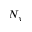Convert formula to latex. <formula><loc_0><loc_0><loc_500><loc_500>N _ { y }</formula> 